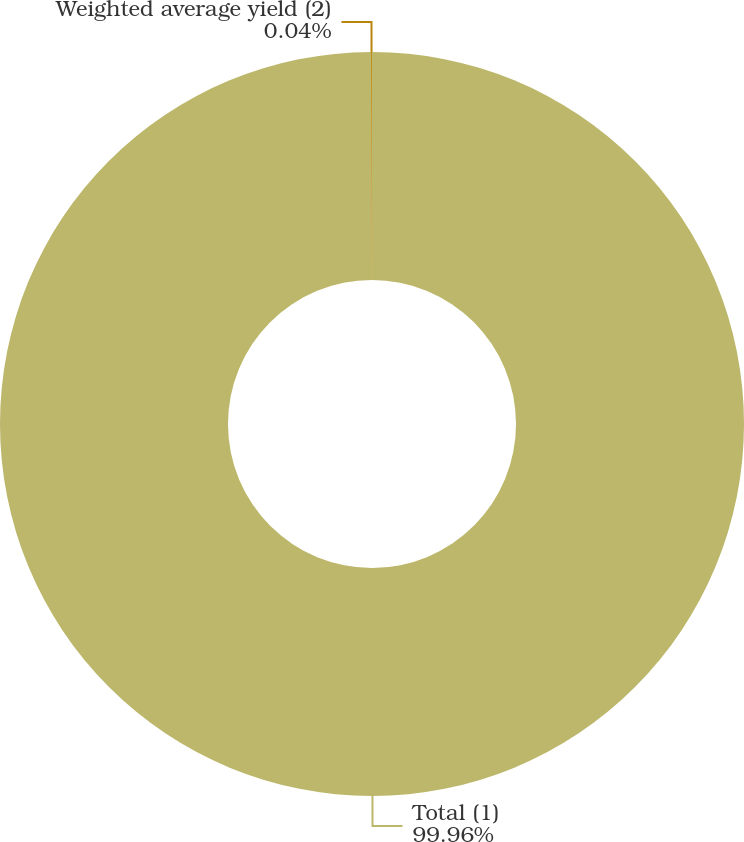<chart> <loc_0><loc_0><loc_500><loc_500><pie_chart><fcel>Total (1)<fcel>Weighted average yield (2)<nl><fcel>99.96%<fcel>0.04%<nl></chart> 